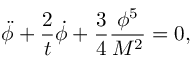<formula> <loc_0><loc_0><loc_500><loc_500>\ddot { \phi } + \frac { 2 } { t } \dot { \phi } + \frac { 3 } { 4 } \frac { \phi ^ { 5 } } { M ^ { 2 } } = 0 ,</formula> 